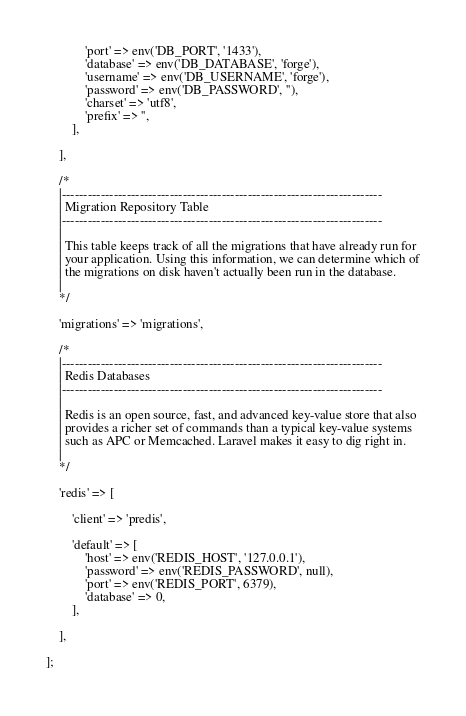Convert code to text. <code><loc_0><loc_0><loc_500><loc_500><_PHP_>            'port' => env('DB_PORT', '1433'),
            'database' => env('DB_DATABASE', 'forge'),
            'username' => env('DB_USERNAME', 'forge'),
            'password' => env('DB_PASSWORD', ''),
            'charset' => 'utf8',
            'prefix' => '',
        ],

    ],

    /*
    |--------------------------------------------------------------------------
    | Migration Repository Table
    |--------------------------------------------------------------------------
    |
    | This table keeps track of all the migrations that have already run for
    | your application. Using this information, we can determine which of
    | the migrations on disk haven't actually been run in the database.
    |
    */

    'migrations' => 'migrations',

    /*
    |--------------------------------------------------------------------------
    | Redis Databases
    |--------------------------------------------------------------------------
    |
    | Redis is an open source, fast, and advanced key-value store that also
    | provides a richer set of commands than a typical key-value systems
    | such as APC or Memcached. Laravel makes it easy to dig right in.
    |
    */

    'redis' => [

        'client' => 'predis',

        'default' => [
            'host' => env('REDIS_HOST', '127.0.0.1'),
            'password' => env('REDIS_PASSWORD', null),
            'port' => env('REDIS_PORT', 6379),
            'database' => 0,
        ],

    ],

];
</code> 